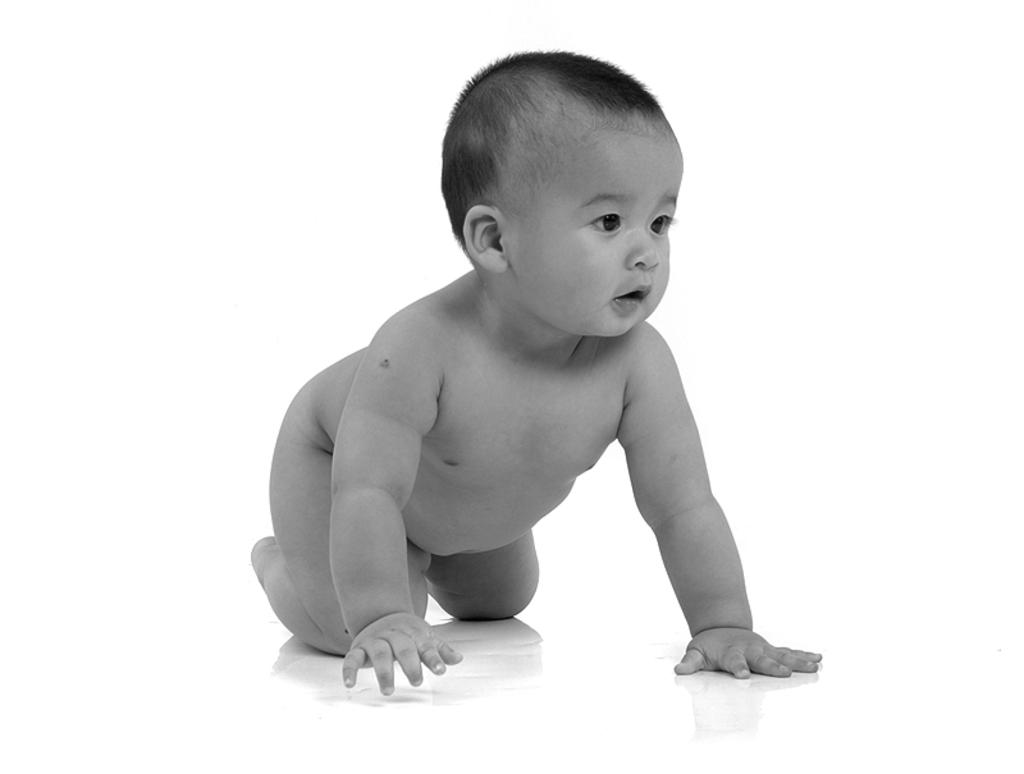What is the main subject of the image? There is a kid in the image. What color is the background of the image? The background of the image is white in color. How many lines can be seen in the image? There is no specific mention of lines in the provided facts, so it is not possible to determine the number of lines in the image. 